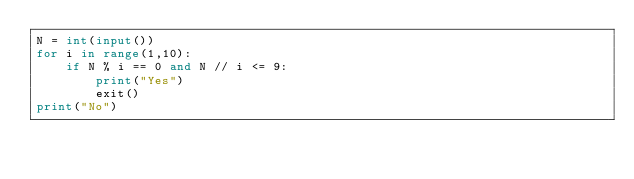<code> <loc_0><loc_0><loc_500><loc_500><_Python_>N = int(input())
for i in range(1,10):
    if N % i == 0 and N // i <= 9:
        print("Yes")
        exit()
print("No")    </code> 